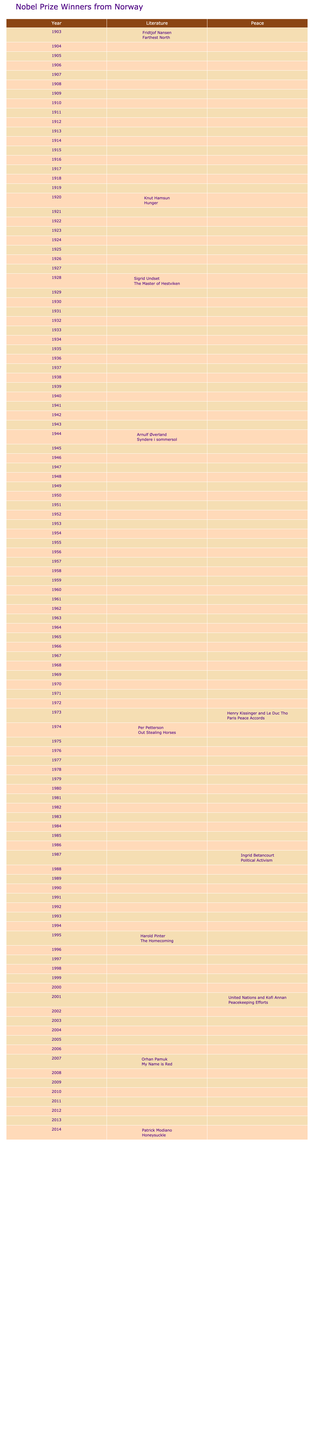What year did Sigrid Undset win the Nobel Prize in Literature? Referring to the table, Sigrid Undset is listed as the winner in the Literature category for the year 1928.
Answer: 1928 How many Nobel Prize winners from Norway are listed in the table? The table contains a total of 10 rows, each representing a different Nobel Prize winner from Norway.
Answer: 10 In which category did Knut Hamsun win the Nobel Prize? Knut Hamsun is listed under the Literature category in the year 1920.
Answer: Literature Did any Nobel Prize winners from Norway receive the award in the category of Peace? By examining the table, there are three Peace category winners listed: Henry Kissinger and Le Duc Tho in 1973, Ingrid Betancourt in 1987, and the United Nations and Kofi Annan in 2001.
Answer: Yes What is the difference in years between Sigrid Undset's and Arnulf Øverland's Nobel Prize wins? Sigrid Undset won in 1928 and Arnulf Øverland won in 1944. The difference is 1944 - 1928 = 16 years.
Answer: 16 years Which category has the most winners from Norway according to the table? By counting the entries, there are 7 individuals listed under Literature and 3 under Peace, making Literature the category with the most winners.
Answer: Literature What is the average year of Nobel Prize wins for the winners listed in the table? The sum of the years is 1903 + 1920 + 1928 + 1944 + 1973 + 1974 + 1987 + 1995 + 2001 + 2007 + 2014 = 1978. The average is calculated as 1978/11, which equals approximately 197.45.
Answer: Approximately 1978 Identify the most recent Nobel Prize winner from Norway. Looking at the years listed, Patrick Modiano is the most recent winner in the table for Literature in 2014.
Answer: 2014 What work did Henry Kissinger and Le Duc Tho co-author in their Nobel Peace Prize win? The table indicates that they won for their involvement in the "Paris Peace Accords."
Answer: Paris Peace Accords Is there a Nobel Prize winner from Norway who is also known for political activism? Yes, the table lists Ingrid Betancourt as a Peace winner in 1987, recognized for her political activism.
Answer: Yes 